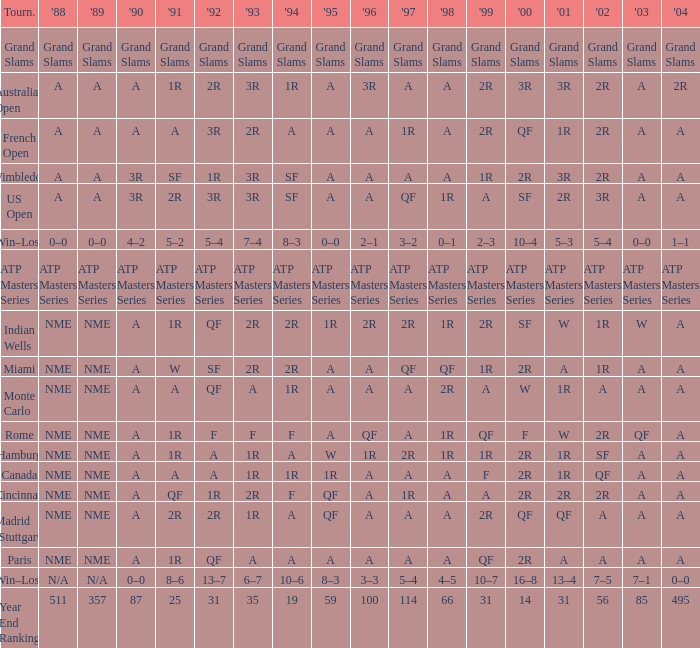What shows for 1992 when 1988 is A, at the Australian Open? 2R. Could you parse the entire table as a dict? {'header': ['Tourn.', "'88", "'89", "'90", "'91", "'92", "'93", "'94", "'95", "'96", "'97", "'98", "'99", "'00", "'01", "'02", "'03", "'04"], 'rows': [['Grand Slams', 'Grand Slams', 'Grand Slams', 'Grand Slams', 'Grand Slams', 'Grand Slams', 'Grand Slams', 'Grand Slams', 'Grand Slams', 'Grand Slams', 'Grand Slams', 'Grand Slams', 'Grand Slams', 'Grand Slams', 'Grand Slams', 'Grand Slams', 'Grand Slams', 'Grand Slams'], ['Australian Open', 'A', 'A', 'A', '1R', '2R', '3R', '1R', 'A', '3R', 'A', 'A', '2R', '3R', '3R', '2R', 'A', '2R'], ['French Open', 'A', 'A', 'A', 'A', '3R', '2R', 'A', 'A', 'A', '1R', 'A', '2R', 'QF', '1R', '2R', 'A', 'A'], ['Wimbledon', 'A', 'A', '3R', 'SF', '1R', '3R', 'SF', 'A', 'A', 'A', 'A', '1R', '2R', '3R', '2R', 'A', 'A'], ['US Open', 'A', 'A', '3R', '2R', '3R', '3R', 'SF', 'A', 'A', 'QF', '1R', 'A', 'SF', '2R', '3R', 'A', 'A'], ['Win–Loss', '0–0', '0–0', '4–2', '5–2', '5–4', '7–4', '8–3', '0–0', '2–1', '3–2', '0–1', '2–3', '10–4', '5–3', '5–4', '0–0', '1–1'], ['ATP Masters Series', 'ATP Masters Series', 'ATP Masters Series', 'ATP Masters Series', 'ATP Masters Series', 'ATP Masters Series', 'ATP Masters Series', 'ATP Masters Series', 'ATP Masters Series', 'ATP Masters Series', 'ATP Masters Series', 'ATP Masters Series', 'ATP Masters Series', 'ATP Masters Series', 'ATP Masters Series', 'ATP Masters Series', 'ATP Masters Series', 'ATP Masters Series'], ['Indian Wells', 'NME', 'NME', 'A', '1R', 'QF', '2R', '2R', '1R', '2R', '2R', '1R', '2R', 'SF', 'W', '1R', 'W', 'A'], ['Miami', 'NME', 'NME', 'A', 'W', 'SF', '2R', '2R', 'A', 'A', 'QF', 'QF', '1R', '2R', 'A', '1R', 'A', 'A'], ['Monte Carlo', 'NME', 'NME', 'A', 'A', 'QF', 'A', '1R', 'A', 'A', 'A', '2R', 'A', 'W', '1R', 'A', 'A', 'A'], ['Rome', 'NME', 'NME', 'A', '1R', 'F', 'F', 'F', 'A', 'QF', 'A', '1R', 'QF', 'F', 'W', '2R', 'QF', 'A'], ['Hamburg', 'NME', 'NME', 'A', '1R', 'A', '1R', 'A', 'W', '1R', '2R', '1R', '1R', '2R', '1R', 'SF', 'A', 'A'], ['Canada', 'NME', 'NME', 'A', 'A', 'A', '1R', '1R', '1R', 'A', 'A', 'A', 'F', '2R', '1R', 'QF', 'A', 'A'], ['Cincinnati', 'NME', 'NME', 'A', 'QF', '1R', '2R', 'F', 'QF', 'A', '1R', 'A', 'A', '2R', '2R', '2R', 'A', 'A'], ['Madrid (Stuttgart)', 'NME', 'NME', 'A', '2R', '2R', '1R', 'A', 'QF', 'A', 'A', 'A', '2R', 'QF', 'QF', 'A', 'A', 'A'], ['Paris', 'NME', 'NME', 'A', '1R', 'QF', 'A', 'A', 'A', 'A', 'A', 'A', 'QF', '2R', 'A', 'A', 'A', 'A'], ['Win–Loss', 'N/A', 'N/A', '0–0', '8–6', '13–7', '6–7', '10–6', '8–3', '3–3', '5–4', '4–5', '10–7', '16–8', '13–4', '7–5', '7–1', '0–0'], ['Year End Ranking', '511', '357', '87', '25', '31', '35', '19', '59', '100', '114', '66', '31', '14', '31', '56', '85', '495']]} 